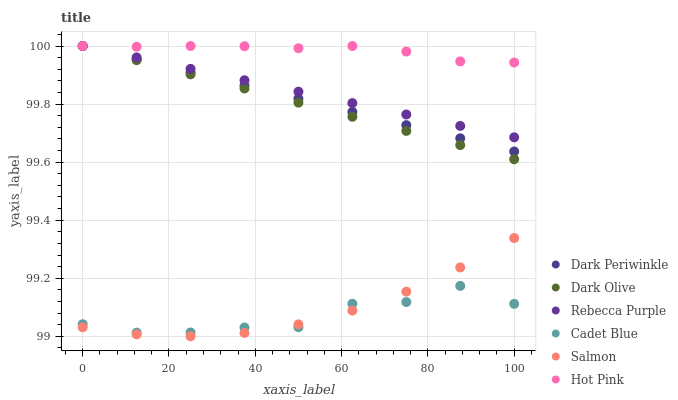Does Cadet Blue have the minimum area under the curve?
Answer yes or no. Yes. Does Hot Pink have the maximum area under the curve?
Answer yes or no. Yes. Does Dark Olive have the minimum area under the curve?
Answer yes or no. No. Does Dark Olive have the maximum area under the curve?
Answer yes or no. No. Is Dark Olive the smoothest?
Answer yes or no. Yes. Is Cadet Blue the roughest?
Answer yes or no. Yes. Is Hot Pink the smoothest?
Answer yes or no. No. Is Hot Pink the roughest?
Answer yes or no. No. Does Salmon have the lowest value?
Answer yes or no. Yes. Does Dark Olive have the lowest value?
Answer yes or no. No. Does Dark Periwinkle have the highest value?
Answer yes or no. Yes. Does Salmon have the highest value?
Answer yes or no. No. Is Cadet Blue less than Dark Olive?
Answer yes or no. Yes. Is Hot Pink greater than Cadet Blue?
Answer yes or no. Yes. Does Dark Olive intersect Dark Periwinkle?
Answer yes or no. Yes. Is Dark Olive less than Dark Periwinkle?
Answer yes or no. No. Is Dark Olive greater than Dark Periwinkle?
Answer yes or no. No. Does Cadet Blue intersect Dark Olive?
Answer yes or no. No. 